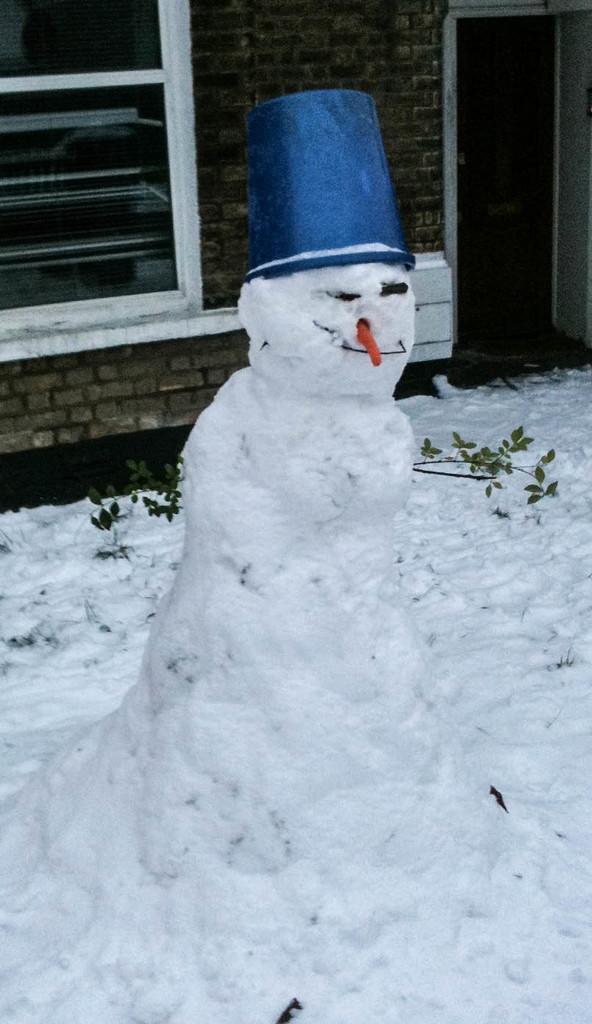Could you give a brief overview of what you see in this image? In this picture I can see a snowman with a hat, and in the background there is a wall with a door and a window. 